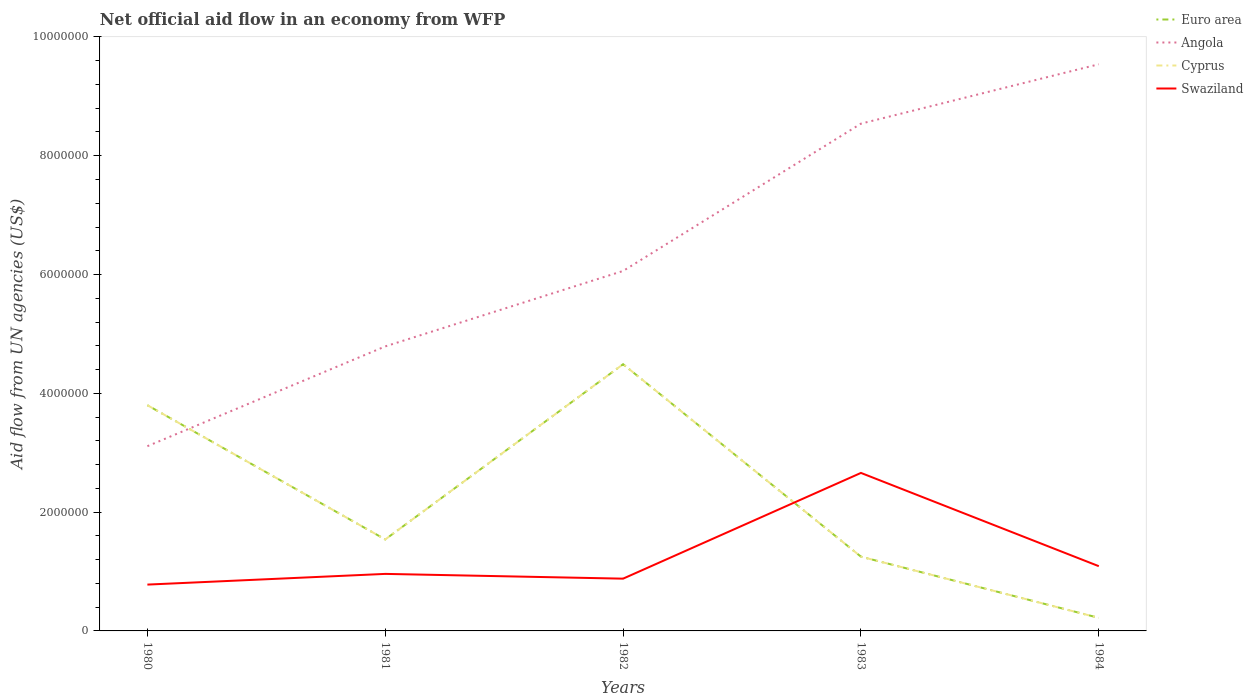Does the line corresponding to Swaziland intersect with the line corresponding to Angola?
Your response must be concise. No. What is the total net official aid flow in Euro area in the graph?
Your answer should be very brief. 1.03e+06. What is the difference between the highest and the second highest net official aid flow in Cyprus?
Ensure brevity in your answer.  4.27e+06. What is the difference between the highest and the lowest net official aid flow in Cyprus?
Your answer should be compact. 2. How many lines are there?
Offer a terse response. 4. What is the difference between two consecutive major ticks on the Y-axis?
Make the answer very short. 2.00e+06. Are the values on the major ticks of Y-axis written in scientific E-notation?
Provide a short and direct response. No. Does the graph contain any zero values?
Offer a terse response. No. Does the graph contain grids?
Offer a terse response. No. Where does the legend appear in the graph?
Give a very brief answer. Top right. How are the legend labels stacked?
Ensure brevity in your answer.  Vertical. What is the title of the graph?
Provide a short and direct response. Net official aid flow in an economy from WFP. Does "Somalia" appear as one of the legend labels in the graph?
Provide a short and direct response. No. What is the label or title of the Y-axis?
Offer a very short reply. Aid flow from UN agencies (US$). What is the Aid flow from UN agencies (US$) of Euro area in 1980?
Your answer should be very brief. 3.80e+06. What is the Aid flow from UN agencies (US$) of Angola in 1980?
Your answer should be very brief. 3.11e+06. What is the Aid flow from UN agencies (US$) in Cyprus in 1980?
Keep it short and to the point. 3.80e+06. What is the Aid flow from UN agencies (US$) in Swaziland in 1980?
Make the answer very short. 7.80e+05. What is the Aid flow from UN agencies (US$) in Euro area in 1981?
Your response must be concise. 1.54e+06. What is the Aid flow from UN agencies (US$) of Angola in 1981?
Make the answer very short. 4.79e+06. What is the Aid flow from UN agencies (US$) in Cyprus in 1981?
Your answer should be very brief. 1.54e+06. What is the Aid flow from UN agencies (US$) in Swaziland in 1981?
Keep it short and to the point. 9.60e+05. What is the Aid flow from UN agencies (US$) in Euro area in 1982?
Your answer should be very brief. 4.49e+06. What is the Aid flow from UN agencies (US$) in Angola in 1982?
Offer a terse response. 6.06e+06. What is the Aid flow from UN agencies (US$) of Cyprus in 1982?
Make the answer very short. 4.49e+06. What is the Aid flow from UN agencies (US$) of Swaziland in 1982?
Offer a very short reply. 8.80e+05. What is the Aid flow from UN agencies (US$) of Euro area in 1983?
Make the answer very short. 1.25e+06. What is the Aid flow from UN agencies (US$) of Angola in 1983?
Ensure brevity in your answer.  8.54e+06. What is the Aid flow from UN agencies (US$) in Cyprus in 1983?
Give a very brief answer. 1.25e+06. What is the Aid flow from UN agencies (US$) in Swaziland in 1983?
Give a very brief answer. 2.66e+06. What is the Aid flow from UN agencies (US$) of Euro area in 1984?
Your response must be concise. 2.20e+05. What is the Aid flow from UN agencies (US$) of Angola in 1984?
Offer a very short reply. 9.54e+06. What is the Aid flow from UN agencies (US$) of Swaziland in 1984?
Keep it short and to the point. 1.09e+06. Across all years, what is the maximum Aid flow from UN agencies (US$) of Euro area?
Keep it short and to the point. 4.49e+06. Across all years, what is the maximum Aid flow from UN agencies (US$) of Angola?
Your response must be concise. 9.54e+06. Across all years, what is the maximum Aid flow from UN agencies (US$) of Cyprus?
Your answer should be very brief. 4.49e+06. Across all years, what is the maximum Aid flow from UN agencies (US$) in Swaziland?
Keep it short and to the point. 2.66e+06. Across all years, what is the minimum Aid flow from UN agencies (US$) in Euro area?
Provide a succinct answer. 2.20e+05. Across all years, what is the minimum Aid flow from UN agencies (US$) in Angola?
Your response must be concise. 3.11e+06. Across all years, what is the minimum Aid flow from UN agencies (US$) in Swaziland?
Provide a short and direct response. 7.80e+05. What is the total Aid flow from UN agencies (US$) of Euro area in the graph?
Your response must be concise. 1.13e+07. What is the total Aid flow from UN agencies (US$) of Angola in the graph?
Your response must be concise. 3.20e+07. What is the total Aid flow from UN agencies (US$) of Cyprus in the graph?
Offer a very short reply. 1.13e+07. What is the total Aid flow from UN agencies (US$) in Swaziland in the graph?
Provide a succinct answer. 6.37e+06. What is the difference between the Aid flow from UN agencies (US$) of Euro area in 1980 and that in 1981?
Make the answer very short. 2.26e+06. What is the difference between the Aid flow from UN agencies (US$) in Angola in 1980 and that in 1981?
Ensure brevity in your answer.  -1.68e+06. What is the difference between the Aid flow from UN agencies (US$) of Cyprus in 1980 and that in 1981?
Provide a short and direct response. 2.26e+06. What is the difference between the Aid flow from UN agencies (US$) in Euro area in 1980 and that in 1982?
Make the answer very short. -6.90e+05. What is the difference between the Aid flow from UN agencies (US$) in Angola in 1980 and that in 1982?
Provide a short and direct response. -2.95e+06. What is the difference between the Aid flow from UN agencies (US$) of Cyprus in 1980 and that in 1982?
Offer a terse response. -6.90e+05. What is the difference between the Aid flow from UN agencies (US$) in Euro area in 1980 and that in 1983?
Give a very brief answer. 2.55e+06. What is the difference between the Aid flow from UN agencies (US$) in Angola in 1980 and that in 1983?
Make the answer very short. -5.43e+06. What is the difference between the Aid flow from UN agencies (US$) in Cyprus in 1980 and that in 1983?
Ensure brevity in your answer.  2.55e+06. What is the difference between the Aid flow from UN agencies (US$) in Swaziland in 1980 and that in 1983?
Provide a short and direct response. -1.88e+06. What is the difference between the Aid flow from UN agencies (US$) in Euro area in 1980 and that in 1984?
Your answer should be compact. 3.58e+06. What is the difference between the Aid flow from UN agencies (US$) of Angola in 1980 and that in 1984?
Your answer should be compact. -6.43e+06. What is the difference between the Aid flow from UN agencies (US$) in Cyprus in 1980 and that in 1984?
Offer a very short reply. 3.58e+06. What is the difference between the Aid flow from UN agencies (US$) of Swaziland in 1980 and that in 1984?
Give a very brief answer. -3.10e+05. What is the difference between the Aid flow from UN agencies (US$) in Euro area in 1981 and that in 1982?
Your response must be concise. -2.95e+06. What is the difference between the Aid flow from UN agencies (US$) in Angola in 1981 and that in 1982?
Offer a very short reply. -1.27e+06. What is the difference between the Aid flow from UN agencies (US$) of Cyprus in 1981 and that in 1982?
Provide a succinct answer. -2.95e+06. What is the difference between the Aid flow from UN agencies (US$) of Swaziland in 1981 and that in 1982?
Provide a succinct answer. 8.00e+04. What is the difference between the Aid flow from UN agencies (US$) in Angola in 1981 and that in 1983?
Provide a succinct answer. -3.75e+06. What is the difference between the Aid flow from UN agencies (US$) in Swaziland in 1981 and that in 1983?
Give a very brief answer. -1.70e+06. What is the difference between the Aid flow from UN agencies (US$) of Euro area in 1981 and that in 1984?
Provide a short and direct response. 1.32e+06. What is the difference between the Aid flow from UN agencies (US$) in Angola in 1981 and that in 1984?
Give a very brief answer. -4.75e+06. What is the difference between the Aid flow from UN agencies (US$) of Cyprus in 1981 and that in 1984?
Your answer should be very brief. 1.32e+06. What is the difference between the Aid flow from UN agencies (US$) of Euro area in 1982 and that in 1983?
Provide a succinct answer. 3.24e+06. What is the difference between the Aid flow from UN agencies (US$) of Angola in 1982 and that in 1983?
Offer a very short reply. -2.48e+06. What is the difference between the Aid flow from UN agencies (US$) of Cyprus in 1982 and that in 1983?
Your answer should be very brief. 3.24e+06. What is the difference between the Aid flow from UN agencies (US$) in Swaziland in 1982 and that in 1983?
Offer a terse response. -1.78e+06. What is the difference between the Aid flow from UN agencies (US$) in Euro area in 1982 and that in 1984?
Your answer should be very brief. 4.27e+06. What is the difference between the Aid flow from UN agencies (US$) in Angola in 1982 and that in 1984?
Your response must be concise. -3.48e+06. What is the difference between the Aid flow from UN agencies (US$) in Cyprus in 1982 and that in 1984?
Offer a terse response. 4.27e+06. What is the difference between the Aid flow from UN agencies (US$) in Euro area in 1983 and that in 1984?
Make the answer very short. 1.03e+06. What is the difference between the Aid flow from UN agencies (US$) in Angola in 1983 and that in 1984?
Your response must be concise. -1.00e+06. What is the difference between the Aid flow from UN agencies (US$) in Cyprus in 1983 and that in 1984?
Provide a succinct answer. 1.03e+06. What is the difference between the Aid flow from UN agencies (US$) in Swaziland in 1983 and that in 1984?
Offer a terse response. 1.57e+06. What is the difference between the Aid flow from UN agencies (US$) of Euro area in 1980 and the Aid flow from UN agencies (US$) of Angola in 1981?
Keep it short and to the point. -9.90e+05. What is the difference between the Aid flow from UN agencies (US$) of Euro area in 1980 and the Aid flow from UN agencies (US$) of Cyprus in 1981?
Make the answer very short. 2.26e+06. What is the difference between the Aid flow from UN agencies (US$) of Euro area in 1980 and the Aid flow from UN agencies (US$) of Swaziland in 1981?
Your answer should be compact. 2.84e+06. What is the difference between the Aid flow from UN agencies (US$) in Angola in 1980 and the Aid flow from UN agencies (US$) in Cyprus in 1981?
Offer a very short reply. 1.57e+06. What is the difference between the Aid flow from UN agencies (US$) in Angola in 1980 and the Aid flow from UN agencies (US$) in Swaziland in 1981?
Ensure brevity in your answer.  2.15e+06. What is the difference between the Aid flow from UN agencies (US$) in Cyprus in 1980 and the Aid flow from UN agencies (US$) in Swaziland in 1981?
Your response must be concise. 2.84e+06. What is the difference between the Aid flow from UN agencies (US$) of Euro area in 1980 and the Aid flow from UN agencies (US$) of Angola in 1982?
Offer a very short reply. -2.26e+06. What is the difference between the Aid flow from UN agencies (US$) in Euro area in 1980 and the Aid flow from UN agencies (US$) in Cyprus in 1982?
Give a very brief answer. -6.90e+05. What is the difference between the Aid flow from UN agencies (US$) in Euro area in 1980 and the Aid flow from UN agencies (US$) in Swaziland in 1982?
Offer a terse response. 2.92e+06. What is the difference between the Aid flow from UN agencies (US$) of Angola in 1980 and the Aid flow from UN agencies (US$) of Cyprus in 1982?
Your answer should be very brief. -1.38e+06. What is the difference between the Aid flow from UN agencies (US$) in Angola in 1980 and the Aid flow from UN agencies (US$) in Swaziland in 1982?
Your answer should be compact. 2.23e+06. What is the difference between the Aid flow from UN agencies (US$) of Cyprus in 1980 and the Aid flow from UN agencies (US$) of Swaziland in 1982?
Provide a short and direct response. 2.92e+06. What is the difference between the Aid flow from UN agencies (US$) of Euro area in 1980 and the Aid flow from UN agencies (US$) of Angola in 1983?
Give a very brief answer. -4.74e+06. What is the difference between the Aid flow from UN agencies (US$) of Euro area in 1980 and the Aid flow from UN agencies (US$) of Cyprus in 1983?
Ensure brevity in your answer.  2.55e+06. What is the difference between the Aid flow from UN agencies (US$) in Euro area in 1980 and the Aid flow from UN agencies (US$) in Swaziland in 1983?
Give a very brief answer. 1.14e+06. What is the difference between the Aid flow from UN agencies (US$) of Angola in 1980 and the Aid flow from UN agencies (US$) of Cyprus in 1983?
Your answer should be compact. 1.86e+06. What is the difference between the Aid flow from UN agencies (US$) of Angola in 1980 and the Aid flow from UN agencies (US$) of Swaziland in 1983?
Ensure brevity in your answer.  4.50e+05. What is the difference between the Aid flow from UN agencies (US$) of Cyprus in 1980 and the Aid flow from UN agencies (US$) of Swaziland in 1983?
Make the answer very short. 1.14e+06. What is the difference between the Aid flow from UN agencies (US$) in Euro area in 1980 and the Aid flow from UN agencies (US$) in Angola in 1984?
Ensure brevity in your answer.  -5.74e+06. What is the difference between the Aid flow from UN agencies (US$) of Euro area in 1980 and the Aid flow from UN agencies (US$) of Cyprus in 1984?
Make the answer very short. 3.58e+06. What is the difference between the Aid flow from UN agencies (US$) of Euro area in 1980 and the Aid flow from UN agencies (US$) of Swaziland in 1984?
Give a very brief answer. 2.71e+06. What is the difference between the Aid flow from UN agencies (US$) of Angola in 1980 and the Aid flow from UN agencies (US$) of Cyprus in 1984?
Your answer should be very brief. 2.89e+06. What is the difference between the Aid flow from UN agencies (US$) in Angola in 1980 and the Aid flow from UN agencies (US$) in Swaziland in 1984?
Provide a succinct answer. 2.02e+06. What is the difference between the Aid flow from UN agencies (US$) in Cyprus in 1980 and the Aid flow from UN agencies (US$) in Swaziland in 1984?
Make the answer very short. 2.71e+06. What is the difference between the Aid flow from UN agencies (US$) in Euro area in 1981 and the Aid flow from UN agencies (US$) in Angola in 1982?
Ensure brevity in your answer.  -4.52e+06. What is the difference between the Aid flow from UN agencies (US$) in Euro area in 1981 and the Aid flow from UN agencies (US$) in Cyprus in 1982?
Your response must be concise. -2.95e+06. What is the difference between the Aid flow from UN agencies (US$) in Angola in 1981 and the Aid flow from UN agencies (US$) in Swaziland in 1982?
Keep it short and to the point. 3.91e+06. What is the difference between the Aid flow from UN agencies (US$) in Cyprus in 1981 and the Aid flow from UN agencies (US$) in Swaziland in 1982?
Provide a short and direct response. 6.60e+05. What is the difference between the Aid flow from UN agencies (US$) in Euro area in 1981 and the Aid flow from UN agencies (US$) in Angola in 1983?
Make the answer very short. -7.00e+06. What is the difference between the Aid flow from UN agencies (US$) of Euro area in 1981 and the Aid flow from UN agencies (US$) of Swaziland in 1983?
Give a very brief answer. -1.12e+06. What is the difference between the Aid flow from UN agencies (US$) in Angola in 1981 and the Aid flow from UN agencies (US$) in Cyprus in 1983?
Provide a succinct answer. 3.54e+06. What is the difference between the Aid flow from UN agencies (US$) in Angola in 1981 and the Aid flow from UN agencies (US$) in Swaziland in 1983?
Offer a terse response. 2.13e+06. What is the difference between the Aid flow from UN agencies (US$) in Cyprus in 1981 and the Aid flow from UN agencies (US$) in Swaziland in 1983?
Provide a short and direct response. -1.12e+06. What is the difference between the Aid flow from UN agencies (US$) in Euro area in 1981 and the Aid flow from UN agencies (US$) in Angola in 1984?
Your answer should be compact. -8.00e+06. What is the difference between the Aid flow from UN agencies (US$) in Euro area in 1981 and the Aid flow from UN agencies (US$) in Cyprus in 1984?
Give a very brief answer. 1.32e+06. What is the difference between the Aid flow from UN agencies (US$) of Angola in 1981 and the Aid flow from UN agencies (US$) of Cyprus in 1984?
Your answer should be very brief. 4.57e+06. What is the difference between the Aid flow from UN agencies (US$) of Angola in 1981 and the Aid flow from UN agencies (US$) of Swaziland in 1984?
Provide a short and direct response. 3.70e+06. What is the difference between the Aid flow from UN agencies (US$) in Euro area in 1982 and the Aid flow from UN agencies (US$) in Angola in 1983?
Provide a short and direct response. -4.05e+06. What is the difference between the Aid flow from UN agencies (US$) of Euro area in 1982 and the Aid flow from UN agencies (US$) of Cyprus in 1983?
Your answer should be very brief. 3.24e+06. What is the difference between the Aid flow from UN agencies (US$) of Euro area in 1982 and the Aid flow from UN agencies (US$) of Swaziland in 1983?
Your answer should be compact. 1.83e+06. What is the difference between the Aid flow from UN agencies (US$) in Angola in 1982 and the Aid flow from UN agencies (US$) in Cyprus in 1983?
Your response must be concise. 4.81e+06. What is the difference between the Aid flow from UN agencies (US$) of Angola in 1982 and the Aid flow from UN agencies (US$) of Swaziland in 1983?
Your response must be concise. 3.40e+06. What is the difference between the Aid flow from UN agencies (US$) in Cyprus in 1982 and the Aid flow from UN agencies (US$) in Swaziland in 1983?
Keep it short and to the point. 1.83e+06. What is the difference between the Aid flow from UN agencies (US$) of Euro area in 1982 and the Aid flow from UN agencies (US$) of Angola in 1984?
Offer a very short reply. -5.05e+06. What is the difference between the Aid flow from UN agencies (US$) of Euro area in 1982 and the Aid flow from UN agencies (US$) of Cyprus in 1984?
Your response must be concise. 4.27e+06. What is the difference between the Aid flow from UN agencies (US$) of Euro area in 1982 and the Aid flow from UN agencies (US$) of Swaziland in 1984?
Give a very brief answer. 3.40e+06. What is the difference between the Aid flow from UN agencies (US$) in Angola in 1982 and the Aid flow from UN agencies (US$) in Cyprus in 1984?
Ensure brevity in your answer.  5.84e+06. What is the difference between the Aid flow from UN agencies (US$) of Angola in 1982 and the Aid flow from UN agencies (US$) of Swaziland in 1984?
Offer a very short reply. 4.97e+06. What is the difference between the Aid flow from UN agencies (US$) in Cyprus in 1982 and the Aid flow from UN agencies (US$) in Swaziland in 1984?
Provide a succinct answer. 3.40e+06. What is the difference between the Aid flow from UN agencies (US$) of Euro area in 1983 and the Aid flow from UN agencies (US$) of Angola in 1984?
Ensure brevity in your answer.  -8.29e+06. What is the difference between the Aid flow from UN agencies (US$) of Euro area in 1983 and the Aid flow from UN agencies (US$) of Cyprus in 1984?
Keep it short and to the point. 1.03e+06. What is the difference between the Aid flow from UN agencies (US$) in Euro area in 1983 and the Aid flow from UN agencies (US$) in Swaziland in 1984?
Your response must be concise. 1.60e+05. What is the difference between the Aid flow from UN agencies (US$) in Angola in 1983 and the Aid flow from UN agencies (US$) in Cyprus in 1984?
Give a very brief answer. 8.32e+06. What is the difference between the Aid flow from UN agencies (US$) in Angola in 1983 and the Aid flow from UN agencies (US$) in Swaziland in 1984?
Keep it short and to the point. 7.45e+06. What is the difference between the Aid flow from UN agencies (US$) of Cyprus in 1983 and the Aid flow from UN agencies (US$) of Swaziland in 1984?
Provide a short and direct response. 1.60e+05. What is the average Aid flow from UN agencies (US$) of Euro area per year?
Provide a short and direct response. 2.26e+06. What is the average Aid flow from UN agencies (US$) in Angola per year?
Ensure brevity in your answer.  6.41e+06. What is the average Aid flow from UN agencies (US$) in Cyprus per year?
Offer a very short reply. 2.26e+06. What is the average Aid flow from UN agencies (US$) in Swaziland per year?
Your answer should be compact. 1.27e+06. In the year 1980, what is the difference between the Aid flow from UN agencies (US$) in Euro area and Aid flow from UN agencies (US$) in Angola?
Your answer should be very brief. 6.90e+05. In the year 1980, what is the difference between the Aid flow from UN agencies (US$) in Euro area and Aid flow from UN agencies (US$) in Swaziland?
Your response must be concise. 3.02e+06. In the year 1980, what is the difference between the Aid flow from UN agencies (US$) of Angola and Aid flow from UN agencies (US$) of Cyprus?
Your answer should be very brief. -6.90e+05. In the year 1980, what is the difference between the Aid flow from UN agencies (US$) of Angola and Aid flow from UN agencies (US$) of Swaziland?
Your answer should be very brief. 2.33e+06. In the year 1980, what is the difference between the Aid flow from UN agencies (US$) of Cyprus and Aid flow from UN agencies (US$) of Swaziland?
Your response must be concise. 3.02e+06. In the year 1981, what is the difference between the Aid flow from UN agencies (US$) of Euro area and Aid flow from UN agencies (US$) of Angola?
Give a very brief answer. -3.25e+06. In the year 1981, what is the difference between the Aid flow from UN agencies (US$) in Euro area and Aid flow from UN agencies (US$) in Swaziland?
Your answer should be compact. 5.80e+05. In the year 1981, what is the difference between the Aid flow from UN agencies (US$) of Angola and Aid flow from UN agencies (US$) of Cyprus?
Ensure brevity in your answer.  3.25e+06. In the year 1981, what is the difference between the Aid flow from UN agencies (US$) of Angola and Aid flow from UN agencies (US$) of Swaziland?
Give a very brief answer. 3.83e+06. In the year 1981, what is the difference between the Aid flow from UN agencies (US$) of Cyprus and Aid flow from UN agencies (US$) of Swaziland?
Your response must be concise. 5.80e+05. In the year 1982, what is the difference between the Aid flow from UN agencies (US$) in Euro area and Aid flow from UN agencies (US$) in Angola?
Give a very brief answer. -1.57e+06. In the year 1982, what is the difference between the Aid flow from UN agencies (US$) in Euro area and Aid flow from UN agencies (US$) in Cyprus?
Make the answer very short. 0. In the year 1982, what is the difference between the Aid flow from UN agencies (US$) in Euro area and Aid flow from UN agencies (US$) in Swaziland?
Your response must be concise. 3.61e+06. In the year 1982, what is the difference between the Aid flow from UN agencies (US$) in Angola and Aid flow from UN agencies (US$) in Cyprus?
Your response must be concise. 1.57e+06. In the year 1982, what is the difference between the Aid flow from UN agencies (US$) in Angola and Aid flow from UN agencies (US$) in Swaziland?
Offer a very short reply. 5.18e+06. In the year 1982, what is the difference between the Aid flow from UN agencies (US$) of Cyprus and Aid flow from UN agencies (US$) of Swaziland?
Make the answer very short. 3.61e+06. In the year 1983, what is the difference between the Aid flow from UN agencies (US$) in Euro area and Aid flow from UN agencies (US$) in Angola?
Provide a succinct answer. -7.29e+06. In the year 1983, what is the difference between the Aid flow from UN agencies (US$) in Euro area and Aid flow from UN agencies (US$) in Swaziland?
Keep it short and to the point. -1.41e+06. In the year 1983, what is the difference between the Aid flow from UN agencies (US$) of Angola and Aid flow from UN agencies (US$) of Cyprus?
Give a very brief answer. 7.29e+06. In the year 1983, what is the difference between the Aid flow from UN agencies (US$) in Angola and Aid flow from UN agencies (US$) in Swaziland?
Your response must be concise. 5.88e+06. In the year 1983, what is the difference between the Aid flow from UN agencies (US$) in Cyprus and Aid flow from UN agencies (US$) in Swaziland?
Ensure brevity in your answer.  -1.41e+06. In the year 1984, what is the difference between the Aid flow from UN agencies (US$) in Euro area and Aid flow from UN agencies (US$) in Angola?
Keep it short and to the point. -9.32e+06. In the year 1984, what is the difference between the Aid flow from UN agencies (US$) in Euro area and Aid flow from UN agencies (US$) in Cyprus?
Provide a succinct answer. 0. In the year 1984, what is the difference between the Aid flow from UN agencies (US$) in Euro area and Aid flow from UN agencies (US$) in Swaziland?
Your answer should be compact. -8.70e+05. In the year 1984, what is the difference between the Aid flow from UN agencies (US$) in Angola and Aid flow from UN agencies (US$) in Cyprus?
Keep it short and to the point. 9.32e+06. In the year 1984, what is the difference between the Aid flow from UN agencies (US$) of Angola and Aid flow from UN agencies (US$) of Swaziland?
Keep it short and to the point. 8.45e+06. In the year 1984, what is the difference between the Aid flow from UN agencies (US$) in Cyprus and Aid flow from UN agencies (US$) in Swaziland?
Keep it short and to the point. -8.70e+05. What is the ratio of the Aid flow from UN agencies (US$) in Euro area in 1980 to that in 1981?
Provide a succinct answer. 2.47. What is the ratio of the Aid flow from UN agencies (US$) of Angola in 1980 to that in 1981?
Offer a terse response. 0.65. What is the ratio of the Aid flow from UN agencies (US$) of Cyprus in 1980 to that in 1981?
Keep it short and to the point. 2.47. What is the ratio of the Aid flow from UN agencies (US$) of Swaziland in 1980 to that in 1981?
Ensure brevity in your answer.  0.81. What is the ratio of the Aid flow from UN agencies (US$) in Euro area in 1980 to that in 1982?
Give a very brief answer. 0.85. What is the ratio of the Aid flow from UN agencies (US$) in Angola in 1980 to that in 1982?
Offer a very short reply. 0.51. What is the ratio of the Aid flow from UN agencies (US$) of Cyprus in 1980 to that in 1982?
Your response must be concise. 0.85. What is the ratio of the Aid flow from UN agencies (US$) of Swaziland in 1980 to that in 1982?
Your answer should be very brief. 0.89. What is the ratio of the Aid flow from UN agencies (US$) in Euro area in 1980 to that in 1983?
Offer a terse response. 3.04. What is the ratio of the Aid flow from UN agencies (US$) of Angola in 1980 to that in 1983?
Provide a short and direct response. 0.36. What is the ratio of the Aid flow from UN agencies (US$) of Cyprus in 1980 to that in 1983?
Your answer should be compact. 3.04. What is the ratio of the Aid flow from UN agencies (US$) of Swaziland in 1980 to that in 1983?
Your answer should be very brief. 0.29. What is the ratio of the Aid flow from UN agencies (US$) of Euro area in 1980 to that in 1984?
Make the answer very short. 17.27. What is the ratio of the Aid flow from UN agencies (US$) in Angola in 1980 to that in 1984?
Keep it short and to the point. 0.33. What is the ratio of the Aid flow from UN agencies (US$) of Cyprus in 1980 to that in 1984?
Keep it short and to the point. 17.27. What is the ratio of the Aid flow from UN agencies (US$) of Swaziland in 1980 to that in 1984?
Offer a terse response. 0.72. What is the ratio of the Aid flow from UN agencies (US$) in Euro area in 1981 to that in 1982?
Provide a succinct answer. 0.34. What is the ratio of the Aid flow from UN agencies (US$) in Angola in 1981 to that in 1982?
Keep it short and to the point. 0.79. What is the ratio of the Aid flow from UN agencies (US$) in Cyprus in 1981 to that in 1982?
Provide a short and direct response. 0.34. What is the ratio of the Aid flow from UN agencies (US$) in Euro area in 1981 to that in 1983?
Your answer should be compact. 1.23. What is the ratio of the Aid flow from UN agencies (US$) of Angola in 1981 to that in 1983?
Your response must be concise. 0.56. What is the ratio of the Aid flow from UN agencies (US$) of Cyprus in 1981 to that in 1983?
Ensure brevity in your answer.  1.23. What is the ratio of the Aid flow from UN agencies (US$) of Swaziland in 1981 to that in 1983?
Your answer should be very brief. 0.36. What is the ratio of the Aid flow from UN agencies (US$) in Euro area in 1981 to that in 1984?
Give a very brief answer. 7. What is the ratio of the Aid flow from UN agencies (US$) in Angola in 1981 to that in 1984?
Give a very brief answer. 0.5. What is the ratio of the Aid flow from UN agencies (US$) in Cyprus in 1981 to that in 1984?
Give a very brief answer. 7. What is the ratio of the Aid flow from UN agencies (US$) in Swaziland in 1981 to that in 1984?
Make the answer very short. 0.88. What is the ratio of the Aid flow from UN agencies (US$) of Euro area in 1982 to that in 1983?
Provide a succinct answer. 3.59. What is the ratio of the Aid flow from UN agencies (US$) in Angola in 1982 to that in 1983?
Your answer should be compact. 0.71. What is the ratio of the Aid flow from UN agencies (US$) of Cyprus in 1982 to that in 1983?
Your answer should be compact. 3.59. What is the ratio of the Aid flow from UN agencies (US$) of Swaziland in 1982 to that in 1983?
Make the answer very short. 0.33. What is the ratio of the Aid flow from UN agencies (US$) in Euro area in 1982 to that in 1984?
Keep it short and to the point. 20.41. What is the ratio of the Aid flow from UN agencies (US$) in Angola in 1982 to that in 1984?
Provide a succinct answer. 0.64. What is the ratio of the Aid flow from UN agencies (US$) in Cyprus in 1982 to that in 1984?
Ensure brevity in your answer.  20.41. What is the ratio of the Aid flow from UN agencies (US$) in Swaziland in 1982 to that in 1984?
Provide a short and direct response. 0.81. What is the ratio of the Aid flow from UN agencies (US$) in Euro area in 1983 to that in 1984?
Your answer should be compact. 5.68. What is the ratio of the Aid flow from UN agencies (US$) in Angola in 1983 to that in 1984?
Offer a terse response. 0.9. What is the ratio of the Aid flow from UN agencies (US$) in Cyprus in 1983 to that in 1984?
Your answer should be very brief. 5.68. What is the ratio of the Aid flow from UN agencies (US$) in Swaziland in 1983 to that in 1984?
Your response must be concise. 2.44. What is the difference between the highest and the second highest Aid flow from UN agencies (US$) of Euro area?
Give a very brief answer. 6.90e+05. What is the difference between the highest and the second highest Aid flow from UN agencies (US$) in Cyprus?
Your answer should be very brief. 6.90e+05. What is the difference between the highest and the second highest Aid flow from UN agencies (US$) of Swaziland?
Offer a very short reply. 1.57e+06. What is the difference between the highest and the lowest Aid flow from UN agencies (US$) in Euro area?
Keep it short and to the point. 4.27e+06. What is the difference between the highest and the lowest Aid flow from UN agencies (US$) of Angola?
Your answer should be very brief. 6.43e+06. What is the difference between the highest and the lowest Aid flow from UN agencies (US$) of Cyprus?
Offer a very short reply. 4.27e+06. What is the difference between the highest and the lowest Aid flow from UN agencies (US$) of Swaziland?
Your response must be concise. 1.88e+06. 